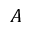<formula> <loc_0><loc_0><loc_500><loc_500>A</formula> 